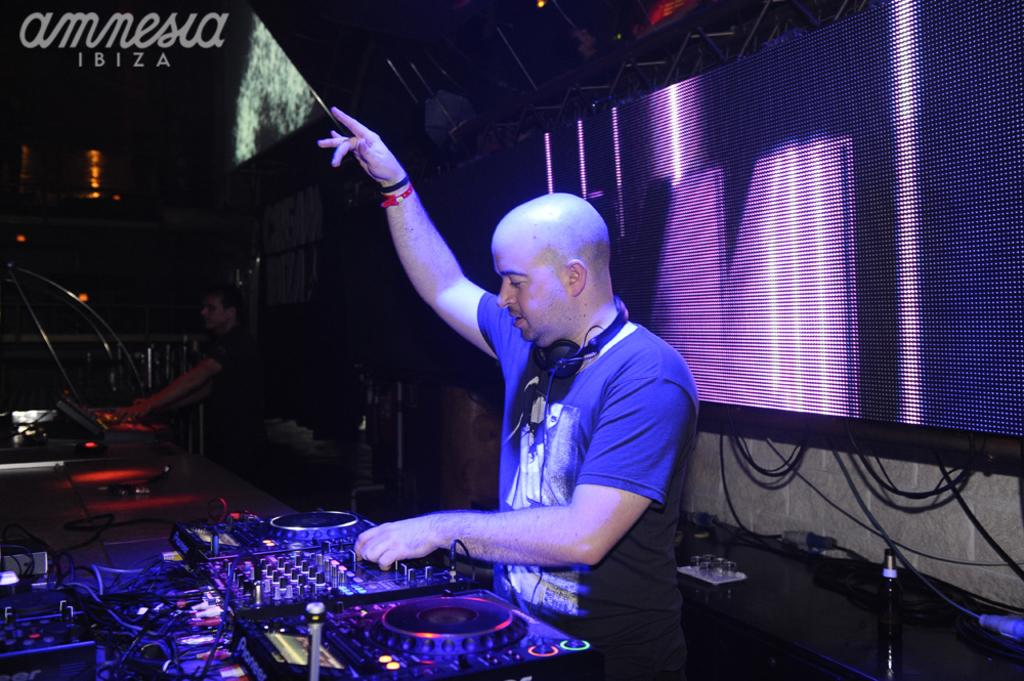How many people are present in the image? There are two people in the image. What can be seen in the image besides the people? There are devices, a screen, wires, and some objects visible in the image. What might be used for displaying information or visuals in the image? There is a screen in the image that can be used for displaying information or visuals. What is present in the top left of the image? There is text visible in the top left of the image. What type of poison is being used by the people in the image? There is no poison present in the image; it features two people interacting with devices and a screen. What kind of cake is being shared by the people in the image? There is no cake present in the image; it features two people interacting with devices and a screen. 